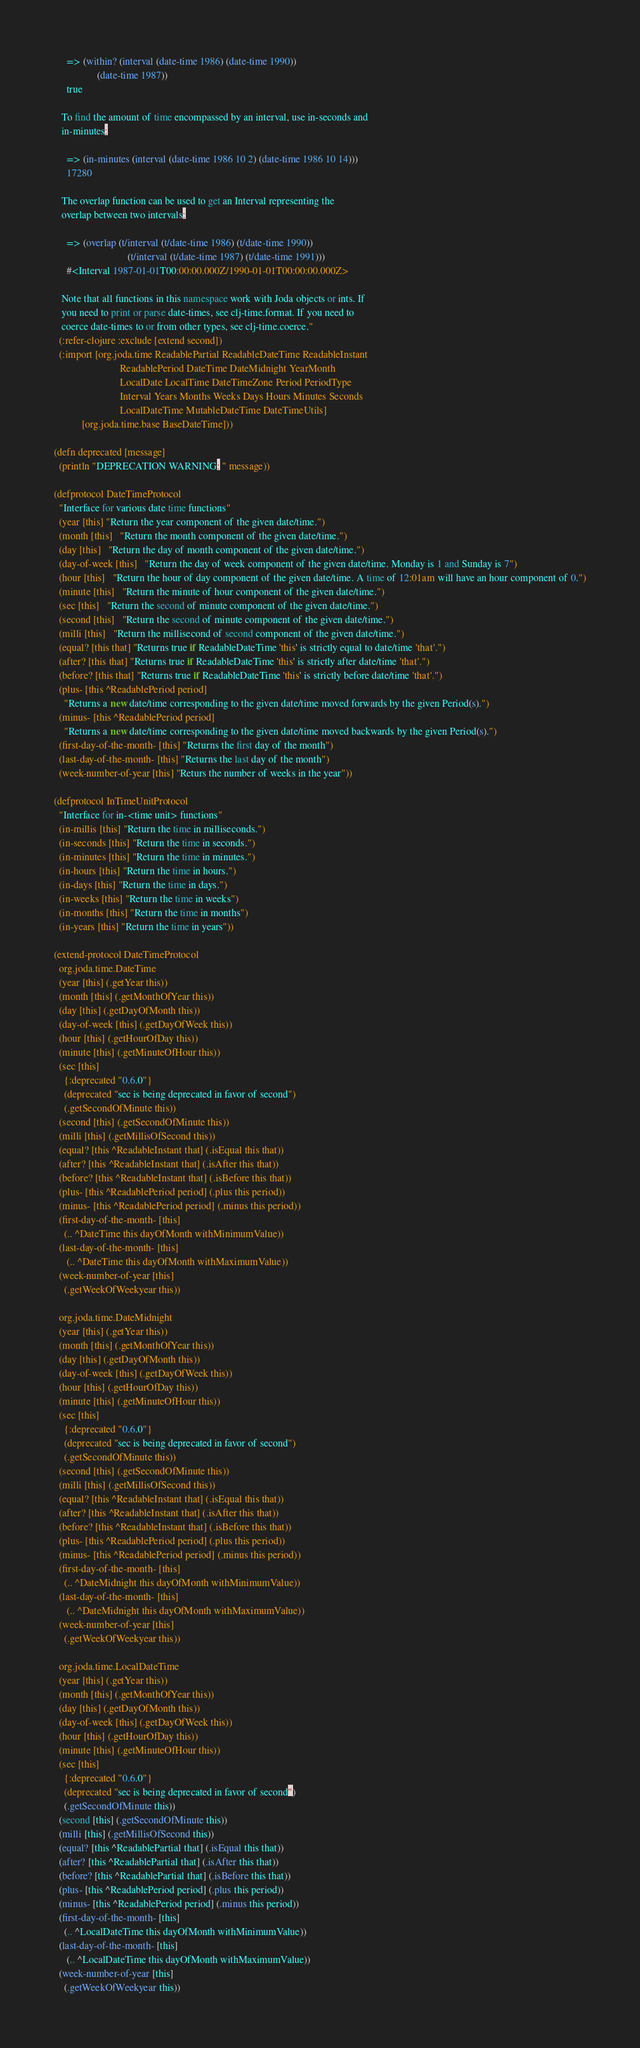<code> <loc_0><loc_0><loc_500><loc_500><_Clojure_>
     => (within? (interval (date-time 1986) (date-time 1990))
                 (date-time 1987))
     true

   To find the amount of time encompassed by an interval, use in-seconds and
   in-minutes:

     => (in-minutes (interval (date-time 1986 10 2) (date-time 1986 10 14)))
     17280

   The overlap function can be used to get an Interval representing the
   overlap between two intervals:

     => (overlap (t/interval (t/date-time 1986) (t/date-time 1990))
                             (t/interval (t/date-time 1987) (t/date-time 1991)))
     #<Interval 1987-01-01T00:00:00.000Z/1990-01-01T00:00:00.000Z>

   Note that all functions in this namespace work with Joda objects or ints. If
   you need to print or parse date-times, see clj-time.format. If you need to
   coerce date-times to or from other types, see clj-time.coerce."
  (:refer-clojure :exclude [extend second])
  (:import [org.joda.time ReadablePartial ReadableDateTime ReadableInstant
                          ReadablePeriod DateTime DateMidnight YearMonth
                          LocalDate LocalTime DateTimeZone Period PeriodType
                          Interval Years Months Weeks Days Hours Minutes Seconds
                          LocalDateTime MutableDateTime DateTimeUtils]
           [org.joda.time.base BaseDateTime]))

(defn deprecated [message]
  (println "DEPRECATION WARNING: " message))

(defprotocol DateTimeProtocol
  "Interface for various date time functions"
  (year [this] "Return the year component of the given date/time.")
  (month [this]   "Return the month component of the given date/time.")
  (day [this]   "Return the day of month component of the given date/time.")
  (day-of-week [this]   "Return the day of week component of the given date/time. Monday is 1 and Sunday is 7")
  (hour [this]   "Return the hour of day component of the given date/time. A time of 12:01am will have an hour component of 0.")
  (minute [this]   "Return the minute of hour component of the given date/time.")
  (sec [this]   "Return the second of minute component of the given date/time.")
  (second [this]   "Return the second of minute component of the given date/time.")
  (milli [this]   "Return the millisecond of second component of the given date/time.")
  (equal? [this that] "Returns true if ReadableDateTime 'this' is strictly equal to date/time 'that'.")
  (after? [this that] "Returns true if ReadableDateTime 'this' is strictly after date/time 'that'.")
  (before? [this that] "Returns true if ReadableDateTime 'this' is strictly before date/time 'that'.")
  (plus- [this ^ReadablePeriod period]
    "Returns a new date/time corresponding to the given date/time moved forwards by the given Period(s).")
  (minus- [this ^ReadablePeriod period]
    "Returns a new date/time corresponding to the given date/time moved backwards by the given Period(s).")
  (first-day-of-the-month- [this] "Returns the first day of the month")
  (last-day-of-the-month- [this] "Returns the last day of the month")
  (week-number-of-year [this] "Returs the number of weeks in the year"))

(defprotocol InTimeUnitProtocol
  "Interface for in-<time unit> functions"
  (in-millis [this] "Return the time in milliseconds.")
  (in-seconds [this] "Return the time in seconds.")
  (in-minutes [this] "Return the time in minutes.")
  (in-hours [this] "Return the time in hours.")
  (in-days [this] "Return the time in days.")
  (in-weeks [this] "Return the time in weeks")
  (in-months [this] "Return the time in months")
  (in-years [this] "Return the time in years"))

(extend-protocol DateTimeProtocol
  org.joda.time.DateTime
  (year [this] (.getYear this))
  (month [this] (.getMonthOfYear this))
  (day [this] (.getDayOfMonth this))
  (day-of-week [this] (.getDayOfWeek this))
  (hour [this] (.getHourOfDay this))
  (minute [this] (.getMinuteOfHour this))
  (sec [this]
    {:deprecated "0.6.0"}
    (deprecated "sec is being deprecated in favor of second")
    (.getSecondOfMinute this))
  (second [this] (.getSecondOfMinute this))
  (milli [this] (.getMillisOfSecond this))
  (equal? [this ^ReadableInstant that] (.isEqual this that))
  (after? [this ^ReadableInstant that] (.isAfter this that))
  (before? [this ^ReadableInstant that] (.isBefore this that))
  (plus- [this ^ReadablePeriod period] (.plus this period))
  (minus- [this ^ReadablePeriod period] (.minus this period))
  (first-day-of-the-month- [this]
    (.. ^DateTime this dayOfMonth withMinimumValue))
  (last-day-of-the-month- [this]
     (.. ^DateTime this dayOfMonth withMaximumValue))
  (week-number-of-year [this]
    (.getWeekOfWeekyear this))

  org.joda.time.DateMidnight
  (year [this] (.getYear this))
  (month [this] (.getMonthOfYear this))
  (day [this] (.getDayOfMonth this))
  (day-of-week [this] (.getDayOfWeek this))
  (hour [this] (.getHourOfDay this))
  (minute [this] (.getMinuteOfHour this))
  (sec [this]
    {:deprecated "0.6.0"}
    (deprecated "sec is being deprecated in favor of second")
    (.getSecondOfMinute this))
  (second [this] (.getSecondOfMinute this))
  (milli [this] (.getMillisOfSecond this))
  (equal? [this ^ReadableInstant that] (.isEqual this that))
  (after? [this ^ReadableInstant that] (.isAfter this that))
  (before? [this ^ReadableInstant that] (.isBefore this that))
  (plus- [this ^ReadablePeriod period] (.plus this period))
  (minus- [this ^ReadablePeriod period] (.minus this period))
  (first-day-of-the-month- [this]
    (.. ^DateMidnight this dayOfMonth withMinimumValue))
  (last-day-of-the-month- [this]
     (.. ^DateMidnight this dayOfMonth withMaximumValue))
  (week-number-of-year [this]
    (.getWeekOfWeekyear this))

  org.joda.time.LocalDateTime
  (year [this] (.getYear this))
  (month [this] (.getMonthOfYear this))
  (day [this] (.getDayOfMonth this))
  (day-of-week [this] (.getDayOfWeek this))
  (hour [this] (.getHourOfDay this))
  (minute [this] (.getMinuteOfHour this))
  (sec [this]
    {:deprecated "0.6.0"}
    (deprecated "sec is being deprecated in favor of second")
    (.getSecondOfMinute this))
  (second [this] (.getSecondOfMinute this))
  (milli [this] (.getMillisOfSecond this))
  (equal? [this ^ReadablePartial that] (.isEqual this that))
  (after? [this ^ReadablePartial that] (.isAfter this that))
  (before? [this ^ReadablePartial that] (.isBefore this that))
  (plus- [this ^ReadablePeriod period] (.plus this period))
  (minus- [this ^ReadablePeriod period] (.minus this period))
  (first-day-of-the-month- [this]
    (.. ^LocalDateTime this dayOfMonth withMinimumValue))
  (last-day-of-the-month- [this]
     (.. ^LocalDateTime this dayOfMonth withMaximumValue))
  (week-number-of-year [this]
    (.getWeekOfWeekyear this))
</code> 